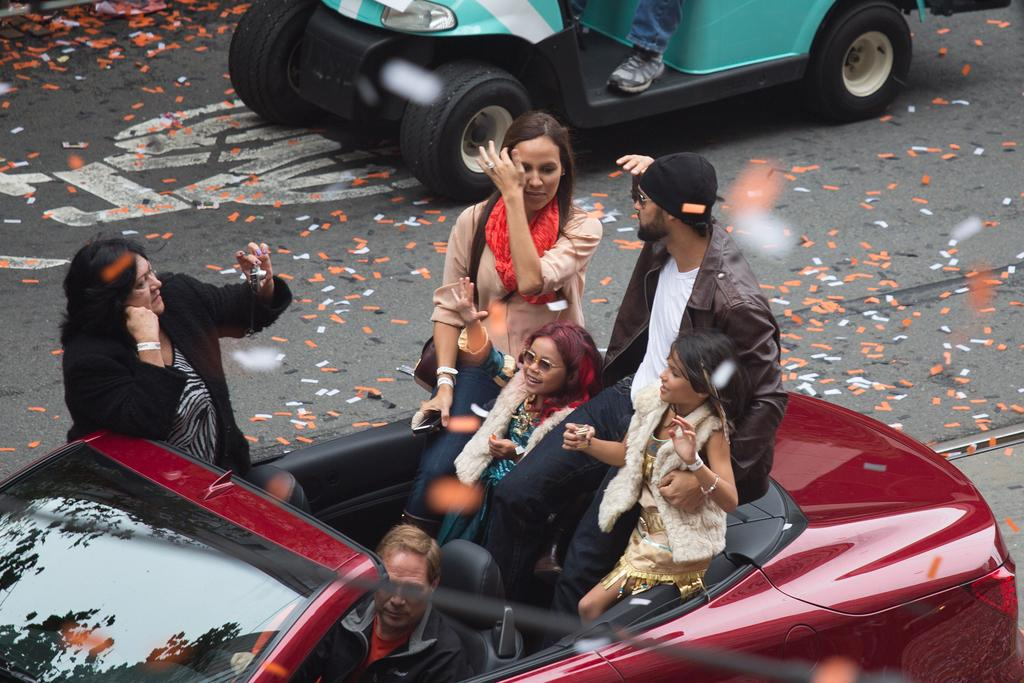What are the people in the image doing? There are persons sitting in a vehicle in the image. Can you describe the attire of one of the persons? One person is wearing a bag. What is another person holding in the image? Another person is holding a glass. What can be seen in the background of the image? There are vehicles visible on the road in the background. What type of magic is being performed by the person wearing the bag in the image? There is no magic being performed in the image; the person is simply wearing a bag. How many steps are visible in the image? There are no steps visible in the image; it features a vehicle with people sitting inside. 